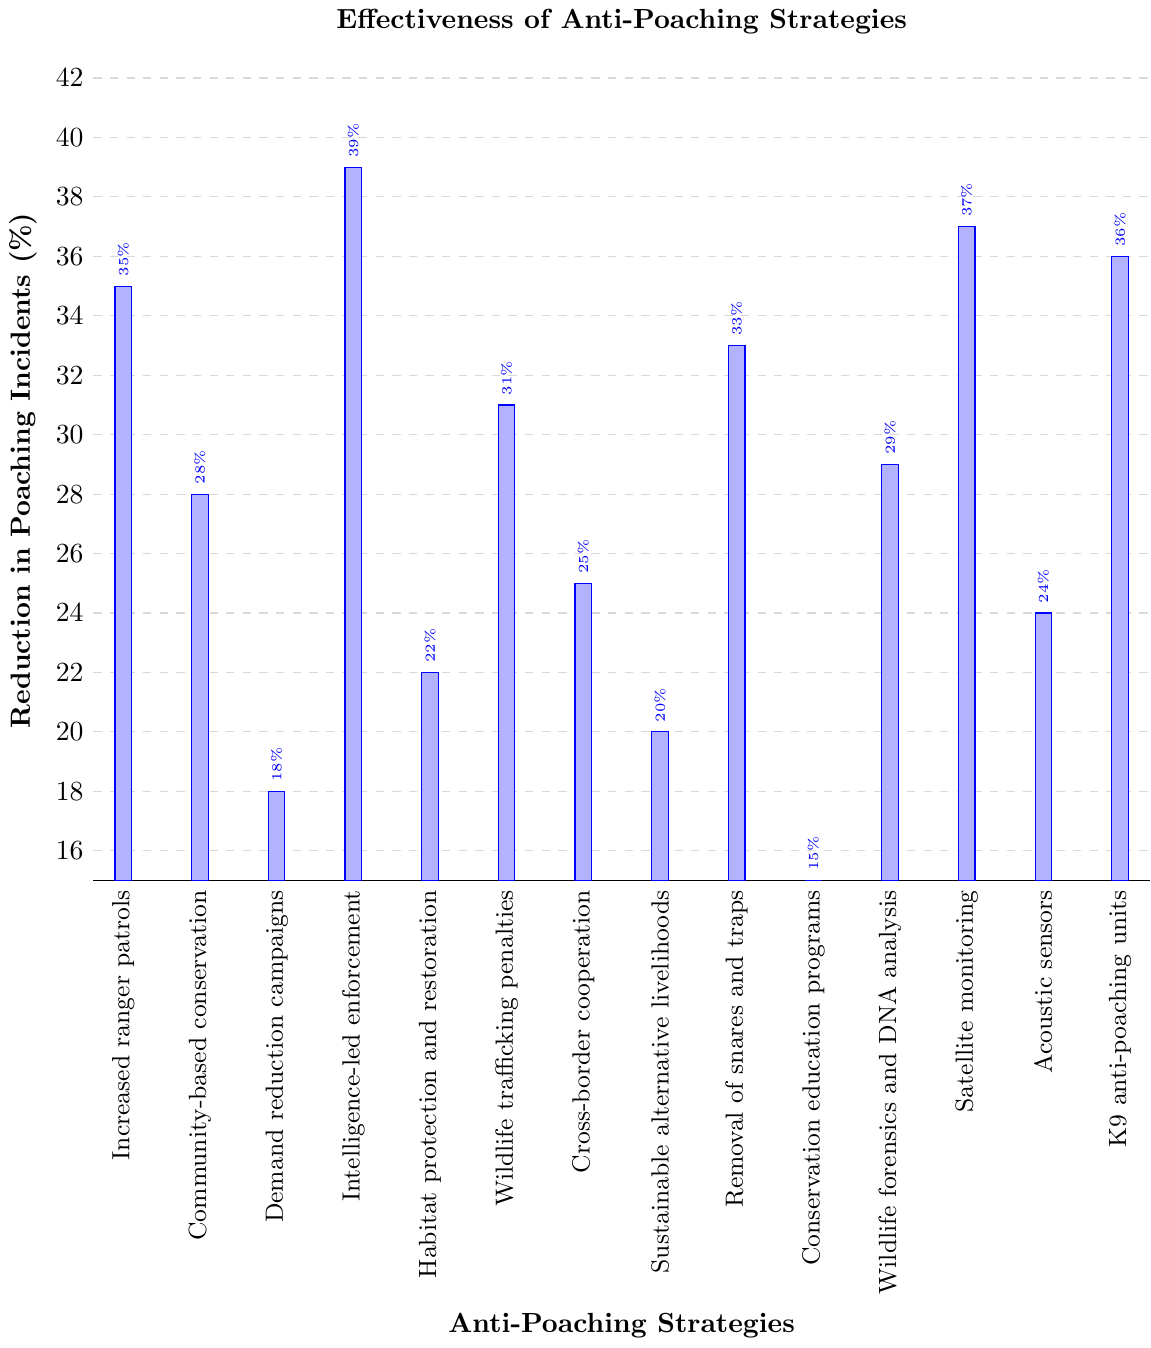Which anti-poaching strategy has the highest reduction in poaching incidents? By looking at the heights of the bars in the figure, identify the bar that reaches the highest value on the y-axis. In this case, the 'Intelligence-led enforcement' bar shows a 39% reduction, which is the highest.
Answer: Intelligence-led enforcement Which strategy is more effective, Wildlife trafficking penalties or Satellite monitoring? Compare the heights of the bars for 'Wildlife trafficking penalties' and 'Satellite monitoring'. 'Satellite monitoring' has a higher percentage (37%) compared to 'Wildlife trafficking penalties' (31%).
Answer: Satellite monitoring What is the combined reduction in poaching incidents for Increased ranger patrols and Removal of snares and traps? Add the reduction percentages for the two strategies. 'Increased ranger patrols' has 35% and 'Removal of snares and traps' has 33%. Thus, 35% + 33% = 68%.
Answer: 68% Among the strategies shown, what is the median reduction in poaching incidents? First, list all the percentages in ascending order: 15, 18, 20, 22, 24, 25, 28, 29, 31, 33, 35, 36, 37, 39. The median is the middle value of this ordered list. Since there are 14 values, the median is the average of the 7th and 8th values: (28 + 29) / 2 = 28.5%.
Answer: 28.5% Which two strategies have the lowest reduction in poaching incidents? Identify the two shortest bars in the figure. 'Conservation education programs' with 15% and 'Demand reduction campaigns' with 18% are the shortest.
Answer: Conservation education programs, Demand reduction campaigns What is the difference in effectiveness between Acoustic sensors and K9 anti-poaching units? Subtract the percentage reduction of 'Acoustic sensors' from 'K9 anti-poaching units'. 'K9 anti-poaching units' has a percentage of 36%, and 'Acoustic sensors' has 24%. So, 36% - 24% = 12%.
Answer: 12% How do Community-based conservation and Habitat protection and restoration compare in terms of reduction percentage? Compare the heights of the bars. 'Community-based conservation' is at 28% and 'Habitat protection and restoration' is at 22%. So, 'Community-based conservation' is higher.
Answer: Community-based conservation Which strategies are above 30% in reduction of poaching incidents? Identify all bars that exceed the 30% mark on the y-axis. These are 'Increased ranger patrols' (35%), 'Intelligence-led enforcement' (39%), 'Satellite monitoring' (37%), 'K9 anti-poaching units' (36%), and 'Wildlife trafficking penalties' (31%).
Answer: Increased ranger patrols, Intelligence-led enforcement, Satellite monitoring, K9 anti-poaching units, Wildlife trafficking penalties 